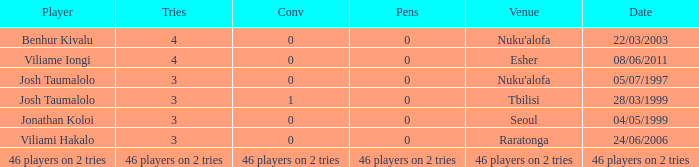What player played on 04/05/1999 with a conv of 0? Jonathan Koloi. 